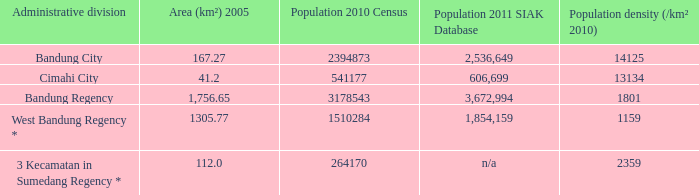What is the population density of the administrative division with a population in 2010 of 264170 according to the census? 2359.0. 